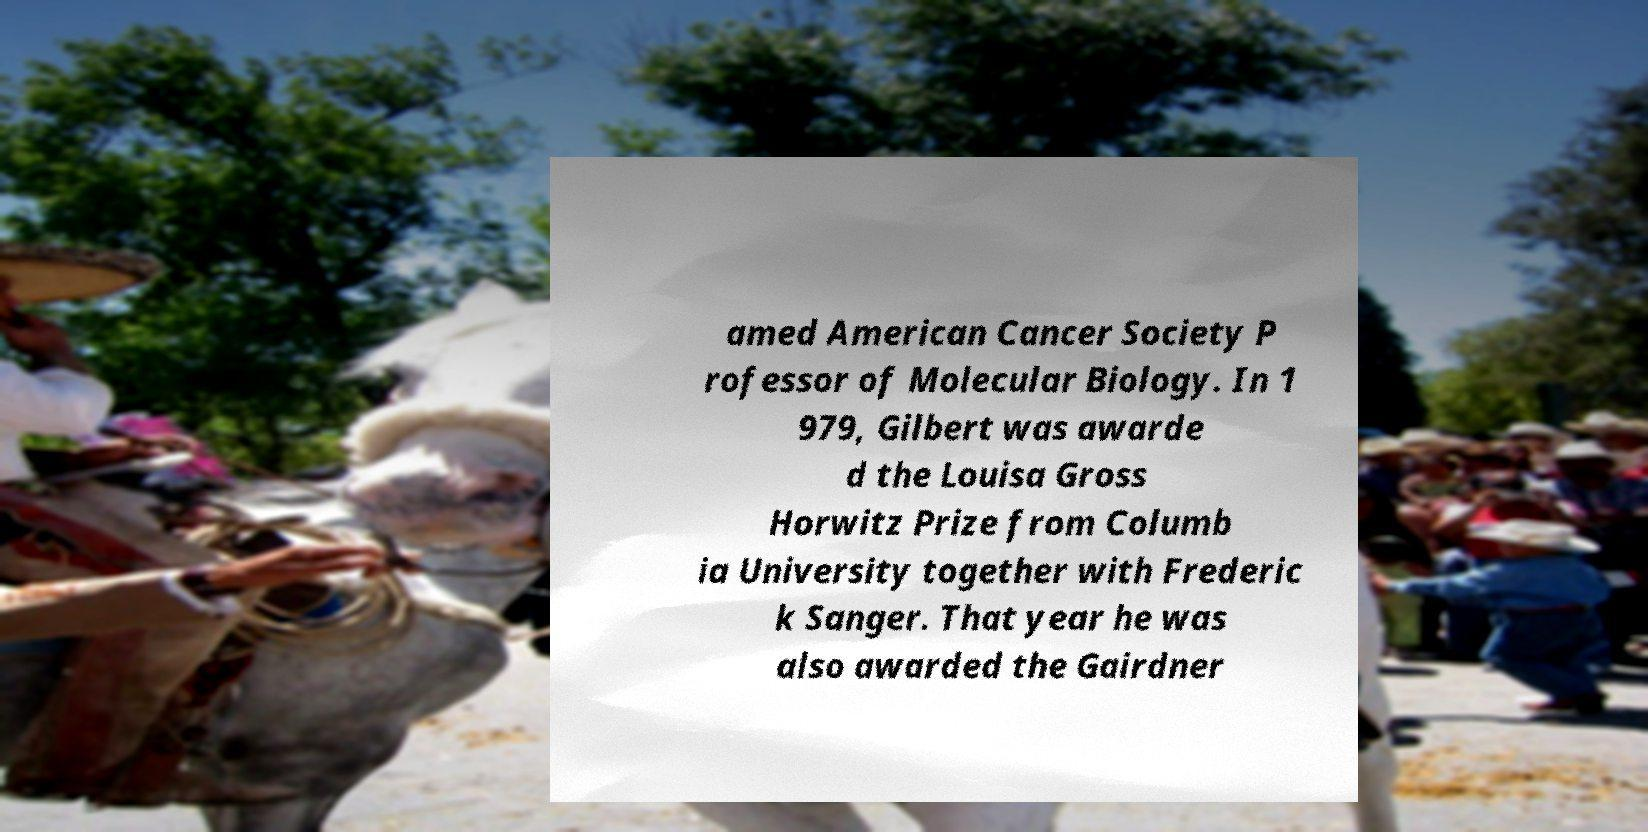Please identify and transcribe the text found in this image. amed American Cancer Society P rofessor of Molecular Biology. In 1 979, Gilbert was awarde d the Louisa Gross Horwitz Prize from Columb ia University together with Frederic k Sanger. That year he was also awarded the Gairdner 